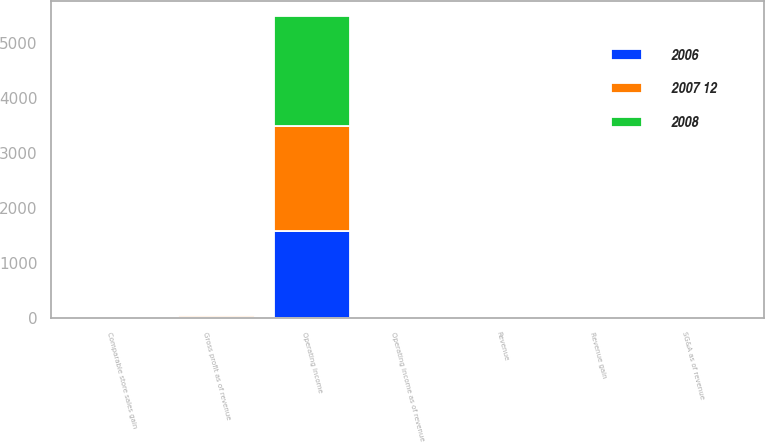Convert chart. <chart><loc_0><loc_0><loc_500><loc_500><stacked_bar_chart><ecel><fcel>Revenue<fcel>Revenue gain<fcel>Comparable store sales gain<fcel>Gross profit as of revenue<fcel>SG&A as of revenue<fcel>Operating income<fcel>Operating income as of revenue<nl><fcel>2008<fcel>15.75<fcel>7<fcel>1.9<fcel>24.5<fcel>18.5<fcel>1999<fcel>6<nl><fcel>2007 12<fcel>15.75<fcel>13<fcel>4.1<fcel>24.8<fcel>18.7<fcel>1900<fcel>6.1<nl><fcel>2006<fcel>15.75<fcel>11<fcel>5.1<fcel>25.3<fcel>19.5<fcel>1588<fcel>5.8<nl></chart> 